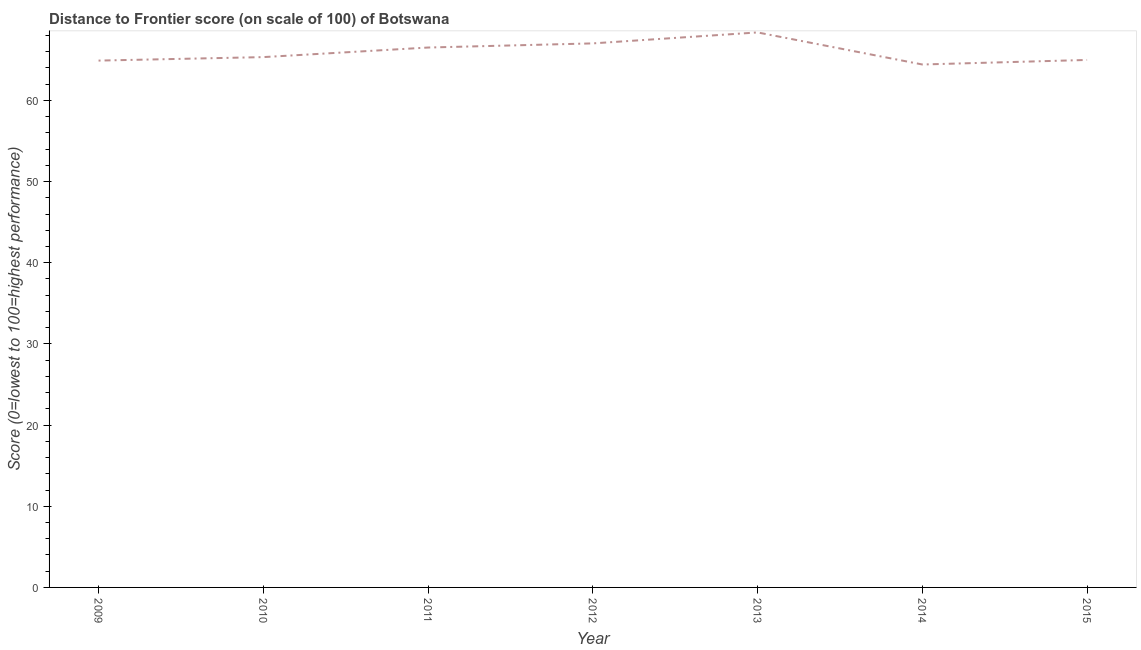What is the distance to frontier score in 2010?
Your answer should be compact. 65.33. Across all years, what is the maximum distance to frontier score?
Give a very brief answer. 68.37. Across all years, what is the minimum distance to frontier score?
Your answer should be compact. 64.42. In which year was the distance to frontier score maximum?
Your answer should be compact. 2013. What is the sum of the distance to frontier score?
Your answer should be very brief. 461.53. What is the difference between the distance to frontier score in 2009 and 2015?
Make the answer very short. -0.08. What is the average distance to frontier score per year?
Your response must be concise. 65.93. What is the median distance to frontier score?
Provide a short and direct response. 65.33. In how many years, is the distance to frontier score greater than 54 ?
Keep it short and to the point. 7. What is the ratio of the distance to frontier score in 2012 to that in 2014?
Give a very brief answer. 1.04. Is the difference between the distance to frontier score in 2013 and 2015 greater than the difference between any two years?
Provide a short and direct response. No. What is the difference between the highest and the second highest distance to frontier score?
Keep it short and to the point. 1.35. Is the sum of the distance to frontier score in 2009 and 2010 greater than the maximum distance to frontier score across all years?
Your answer should be very brief. Yes. What is the difference between the highest and the lowest distance to frontier score?
Your response must be concise. 3.95. How many lines are there?
Offer a terse response. 1. Does the graph contain any zero values?
Your answer should be compact. No. What is the title of the graph?
Your answer should be very brief. Distance to Frontier score (on scale of 100) of Botswana. What is the label or title of the X-axis?
Provide a succinct answer. Year. What is the label or title of the Y-axis?
Your answer should be compact. Score (0=lowest to 100=highest performance). What is the Score (0=lowest to 100=highest performance) in 2009?
Give a very brief answer. 64.9. What is the Score (0=lowest to 100=highest performance) in 2010?
Make the answer very short. 65.33. What is the Score (0=lowest to 100=highest performance) of 2011?
Your answer should be compact. 66.51. What is the Score (0=lowest to 100=highest performance) of 2012?
Your answer should be compact. 67.02. What is the Score (0=lowest to 100=highest performance) in 2013?
Keep it short and to the point. 68.37. What is the Score (0=lowest to 100=highest performance) of 2014?
Keep it short and to the point. 64.42. What is the Score (0=lowest to 100=highest performance) in 2015?
Your answer should be compact. 64.98. What is the difference between the Score (0=lowest to 100=highest performance) in 2009 and 2010?
Give a very brief answer. -0.43. What is the difference between the Score (0=lowest to 100=highest performance) in 2009 and 2011?
Make the answer very short. -1.61. What is the difference between the Score (0=lowest to 100=highest performance) in 2009 and 2012?
Keep it short and to the point. -2.12. What is the difference between the Score (0=lowest to 100=highest performance) in 2009 and 2013?
Your response must be concise. -3.47. What is the difference between the Score (0=lowest to 100=highest performance) in 2009 and 2014?
Keep it short and to the point. 0.48. What is the difference between the Score (0=lowest to 100=highest performance) in 2009 and 2015?
Make the answer very short. -0.08. What is the difference between the Score (0=lowest to 100=highest performance) in 2010 and 2011?
Your response must be concise. -1.18. What is the difference between the Score (0=lowest to 100=highest performance) in 2010 and 2012?
Give a very brief answer. -1.69. What is the difference between the Score (0=lowest to 100=highest performance) in 2010 and 2013?
Your answer should be compact. -3.04. What is the difference between the Score (0=lowest to 100=highest performance) in 2010 and 2014?
Your response must be concise. 0.91. What is the difference between the Score (0=lowest to 100=highest performance) in 2011 and 2012?
Your answer should be very brief. -0.51. What is the difference between the Score (0=lowest to 100=highest performance) in 2011 and 2013?
Your answer should be compact. -1.86. What is the difference between the Score (0=lowest to 100=highest performance) in 2011 and 2014?
Your answer should be compact. 2.09. What is the difference between the Score (0=lowest to 100=highest performance) in 2011 and 2015?
Your response must be concise. 1.53. What is the difference between the Score (0=lowest to 100=highest performance) in 2012 and 2013?
Your answer should be compact. -1.35. What is the difference between the Score (0=lowest to 100=highest performance) in 2012 and 2015?
Give a very brief answer. 2.04. What is the difference between the Score (0=lowest to 100=highest performance) in 2013 and 2014?
Make the answer very short. 3.95. What is the difference between the Score (0=lowest to 100=highest performance) in 2013 and 2015?
Ensure brevity in your answer.  3.39. What is the difference between the Score (0=lowest to 100=highest performance) in 2014 and 2015?
Provide a short and direct response. -0.56. What is the ratio of the Score (0=lowest to 100=highest performance) in 2009 to that in 2013?
Make the answer very short. 0.95. What is the ratio of the Score (0=lowest to 100=highest performance) in 2009 to that in 2014?
Ensure brevity in your answer.  1.01. What is the ratio of the Score (0=lowest to 100=highest performance) in 2010 to that in 2011?
Offer a very short reply. 0.98. What is the ratio of the Score (0=lowest to 100=highest performance) in 2010 to that in 2013?
Ensure brevity in your answer.  0.96. What is the ratio of the Score (0=lowest to 100=highest performance) in 2010 to that in 2014?
Your answer should be compact. 1.01. What is the ratio of the Score (0=lowest to 100=highest performance) in 2011 to that in 2012?
Provide a short and direct response. 0.99. What is the ratio of the Score (0=lowest to 100=highest performance) in 2011 to that in 2013?
Your response must be concise. 0.97. What is the ratio of the Score (0=lowest to 100=highest performance) in 2011 to that in 2014?
Your response must be concise. 1.03. What is the ratio of the Score (0=lowest to 100=highest performance) in 2012 to that in 2014?
Provide a succinct answer. 1.04. What is the ratio of the Score (0=lowest to 100=highest performance) in 2012 to that in 2015?
Offer a very short reply. 1.03. What is the ratio of the Score (0=lowest to 100=highest performance) in 2013 to that in 2014?
Provide a succinct answer. 1.06. What is the ratio of the Score (0=lowest to 100=highest performance) in 2013 to that in 2015?
Your answer should be compact. 1.05. 